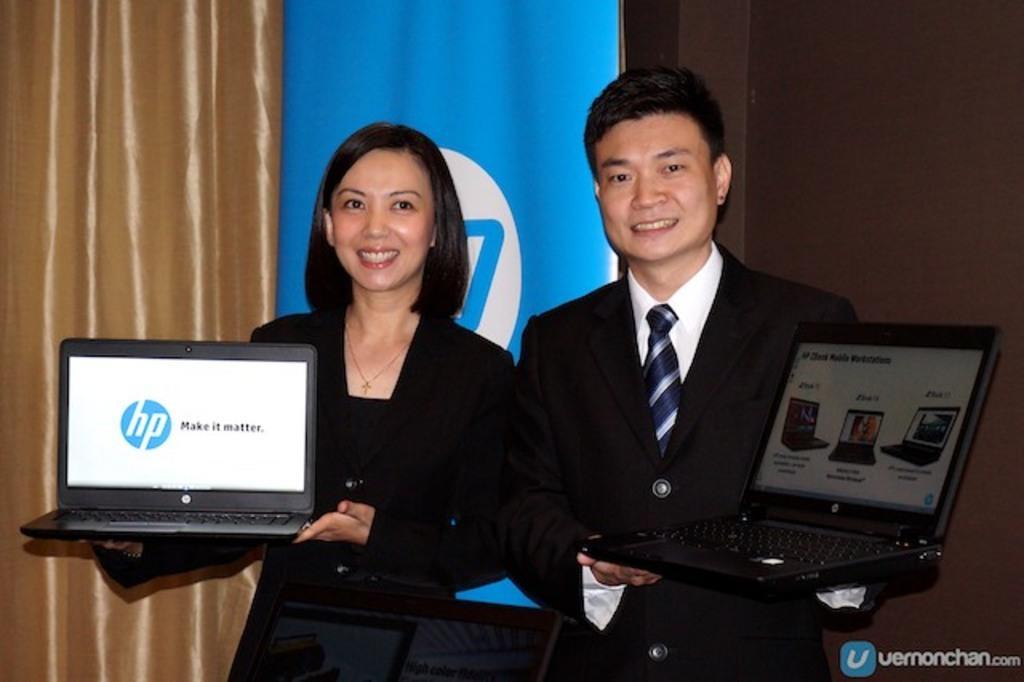Could you give a brief overview of what you see in this image? In this image we can see two persons with smiling face standing and holding laptops. There is one blue banner with text near the wall, one curtain in the background on the left side of the image, some text on the bottom right side corner of the image, three laptops with text and images. 